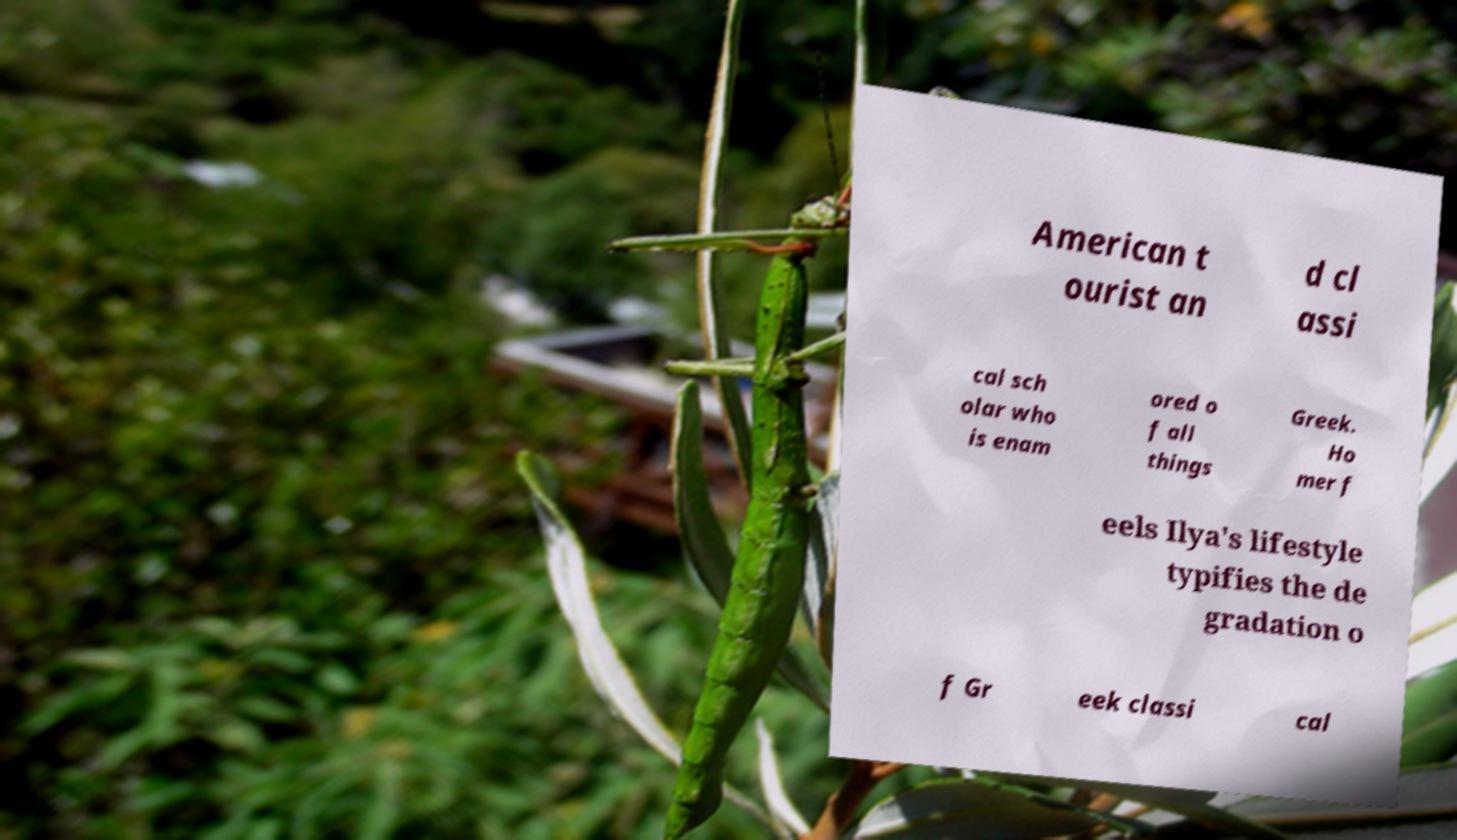Could you extract and type out the text from this image? American t ourist an d cl assi cal sch olar who is enam ored o f all things Greek. Ho mer f eels Ilya's lifestyle typifies the de gradation o f Gr eek classi cal 